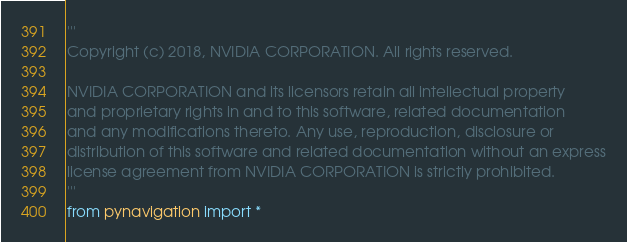Convert code to text. <code><loc_0><loc_0><loc_500><loc_500><_Python_>'''
Copyright (c) 2018, NVIDIA CORPORATION. All rights reserved.

NVIDIA CORPORATION and its licensors retain all intellectual property
and proprietary rights in and to this software, related documentation
and any modifications thereto. Any use, reproduction, disclosure or
distribution of this software and related documentation without an express
license agreement from NVIDIA CORPORATION is strictly prohibited.
'''
from pynavigation import *

</code> 